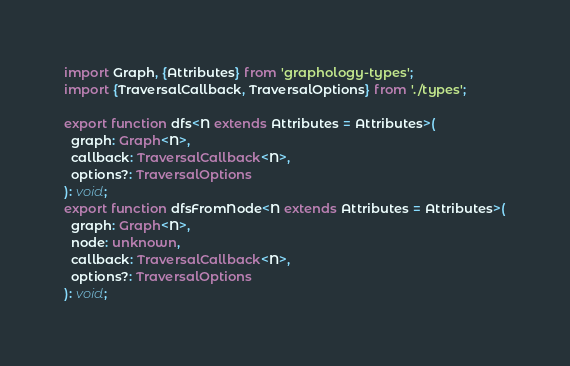<code> <loc_0><loc_0><loc_500><loc_500><_TypeScript_>import Graph, {Attributes} from 'graphology-types';
import {TraversalCallback, TraversalOptions} from './types';

export function dfs<N extends Attributes = Attributes>(
  graph: Graph<N>,
  callback: TraversalCallback<N>,
  options?: TraversalOptions
): void;
export function dfsFromNode<N extends Attributes = Attributes>(
  graph: Graph<N>,
  node: unknown,
  callback: TraversalCallback<N>,
  options?: TraversalOptions
): void;
</code> 